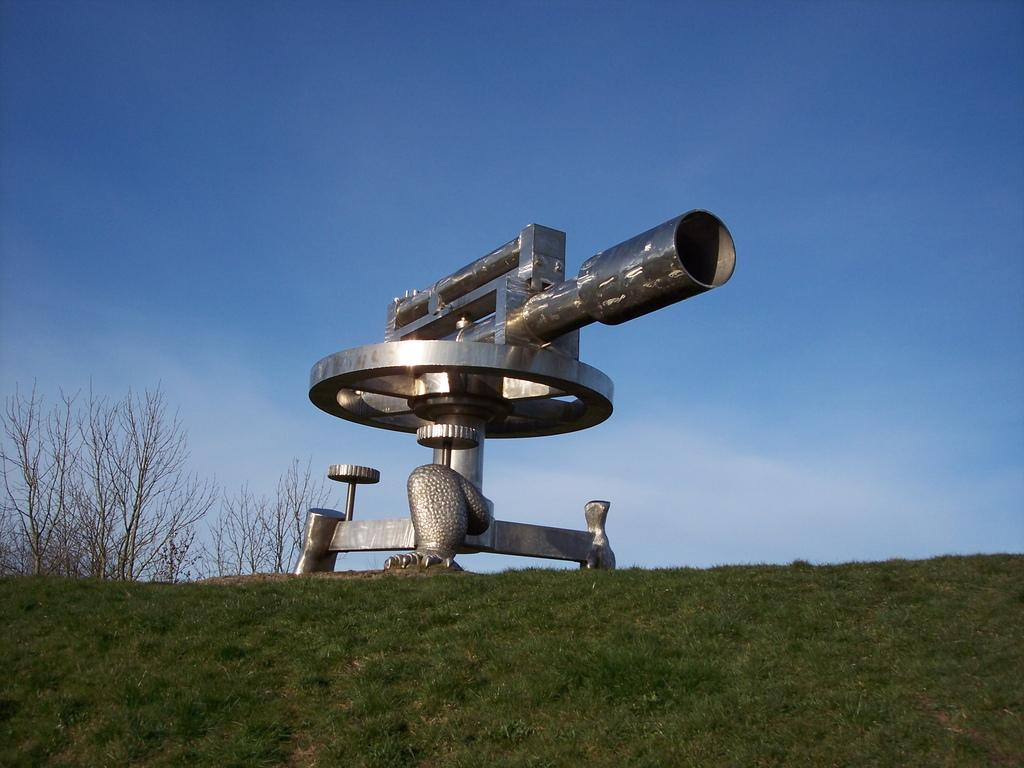What is the main subject in the center of the image? There is a statue in the center of the image. What type of ground is visible at the bottom of the image? There is grass at the bottom of the image. What can be seen in the background of the image? The sky and trees are visible in the background of the image. Where is the hose located in the image? There is no hose present in the image. What type of creature can be seen interacting with the statue in the image? There is no creature present in the image; it only features a statue, grass, and trees. 